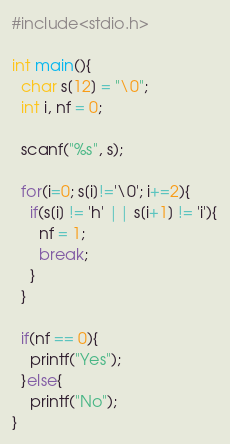<code> <loc_0><loc_0><loc_500><loc_500><_C_>#include<stdio.h>

int main(){
  char s[12] = "\0";
  int i, nf = 0;
  
  scanf("%s", s);
  
  for(i=0; s[i]!='\0'; i+=2){
    if(s[i] != 'h' || s[i+1] != 'i'){
      nf = 1;
      break;
    }
  }
  
  if(nf == 0){
    printf("Yes");
  }else{
    printf("No");
}</code> 